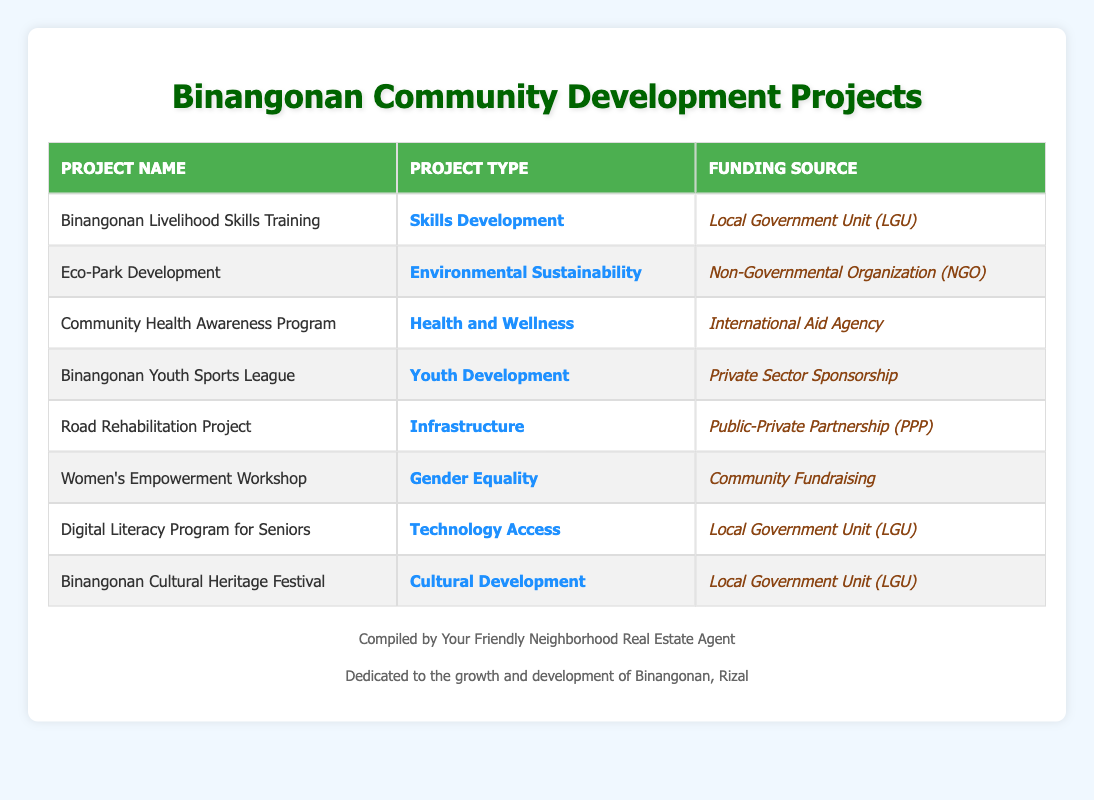What is the funding source for the Binangonan Youth Sports League? The funding source for the Binangonan Youth Sports League is listed in the table as Private Sector Sponsorship. Therefore, the answer is directly retrieved from the row corresponding to this project.
Answer: Private Sector Sponsorship How many projects are funded by the Local Government Unit (LGU)? By examining the table, we see that three projects (Binangonan Livelihood Skills Training, Digital Literacy Program for Seniors, and Binangonan Cultural Heritage Festival) have Local Government Unit (LGU) listed as their funding source. We count these instances to get the total.
Answer: 3 Is there a project related to Environmental Sustainability funded by a Non-Governmental Organization (NGO)? Yes, the Eco-Park Development project is categorized under Environmental Sustainability and funded by a Non-Governmental Organization (NGO). Thus, this claim is affirmed by referring to the respective row.
Answer: Yes Which project type has the most diverse funding sources? We analyze the projects, noting each type and collect their corresponding funding sources. The project types are (Skills Development, Environmental Sustainability, Health and Wellness, Youth Development, Infrastructure, Gender Equality, Technology Access, Cultural Development), and we tally them up, finding that each type has a different number of unique funding sources. However, most types (except for Community Fundraising and International Aid) appear just once. Therefore, Infrastructure has the most, with Public-Private Partnership as its source.
Answer: Infrastructure What is the total number of community development projects listed in the table? Counting the number of rows in the table provides the total number of projects. Each row signifies one project, producing a total of eight entries. Thus, we arrive at the total number.
Answer: 8 